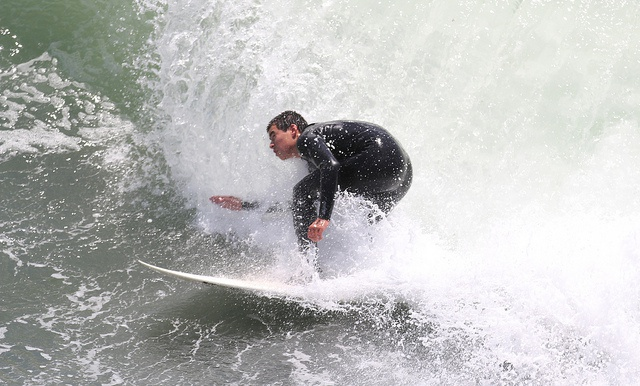Describe the objects in this image and their specific colors. I can see people in gray, black, darkgray, and lightgray tones and surfboard in gray, white, and darkgray tones in this image. 